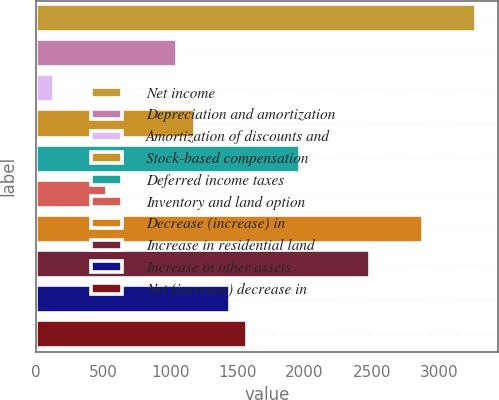Convert chart to OTSL. <chart><loc_0><loc_0><loc_500><loc_500><bar_chart><fcel>Net income<fcel>Depreciation and amortization<fcel>Amortization of discounts and<fcel>Stock-based compensation<fcel>Deferred income taxes<fcel>Inventory and land option<fcel>Decrease (increase) in<fcel>Increase in residential land<fcel>Increase in other assets<fcel>Net (increase) decrease in<nl><fcel>3275.6<fcel>1050.98<fcel>134.96<fcel>1181.84<fcel>1967<fcel>527.54<fcel>2883.02<fcel>2490.44<fcel>1443.56<fcel>1574.42<nl></chart> 